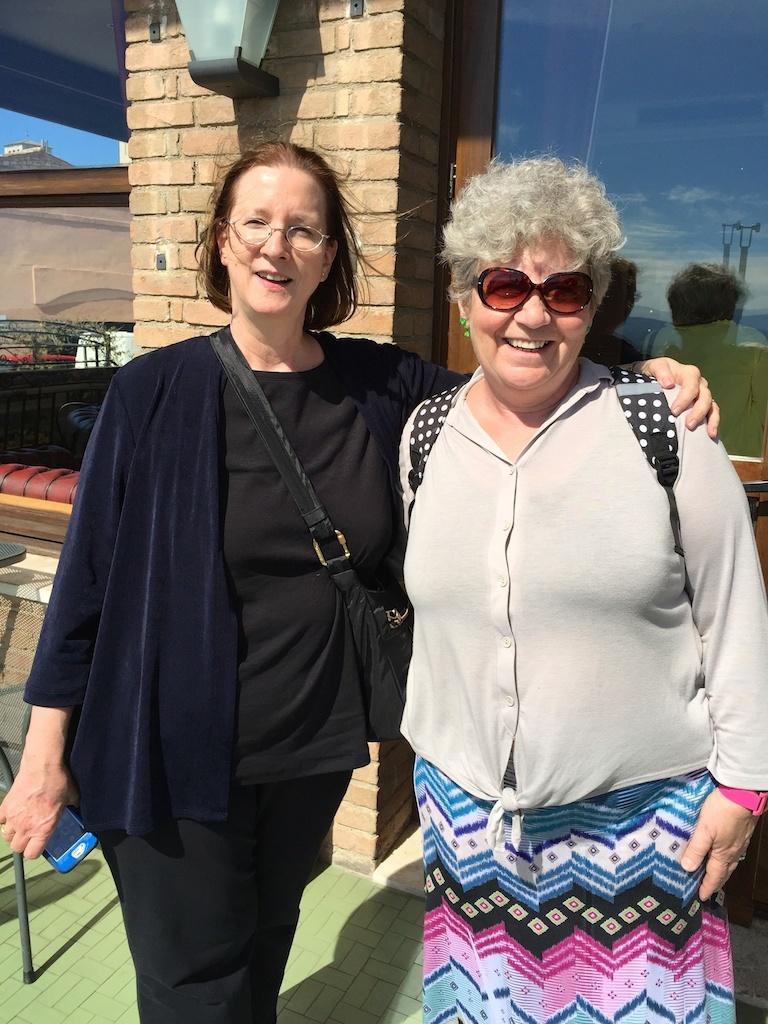Can you describe this image briefly? In the image on the left side there is a lady with spectacles is standing and she is smiling. And she wore a bag and she is holding an object in the hand. Beside her on the right side there is a lady with goggles is smiling and she is standing. Behind them there is a brick pillar and also there is a glass door. On the left corner of the image there are few things. 